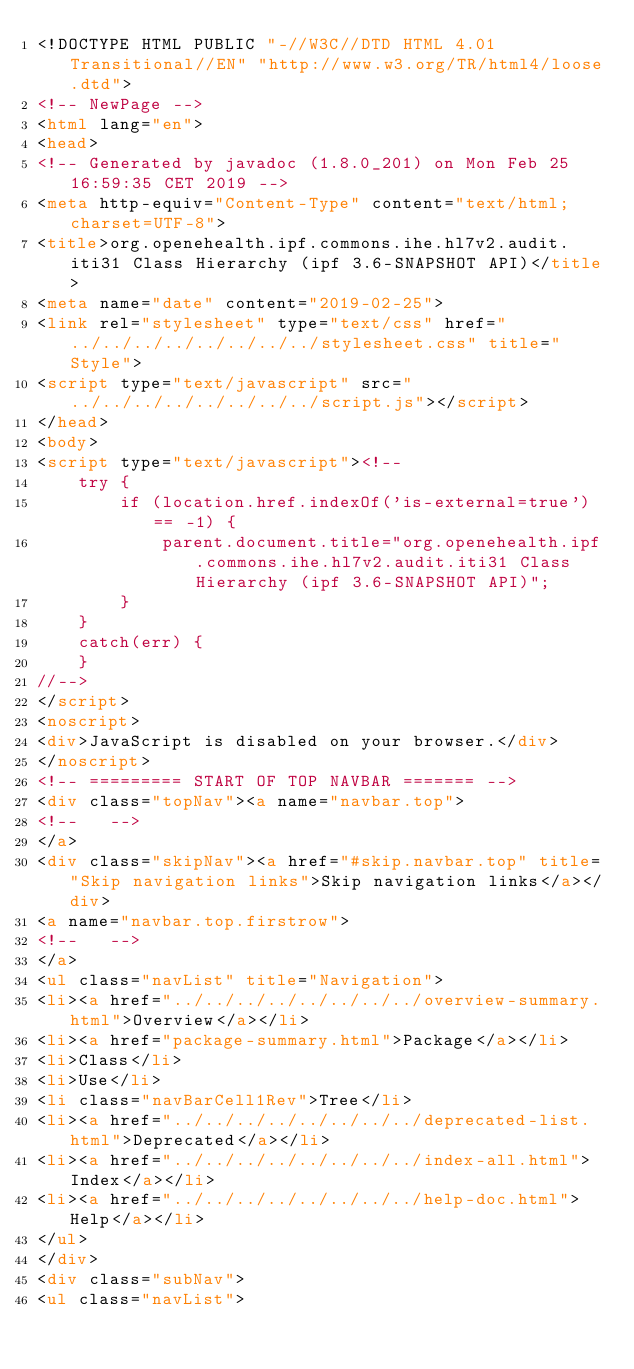Convert code to text. <code><loc_0><loc_0><loc_500><loc_500><_HTML_><!DOCTYPE HTML PUBLIC "-//W3C//DTD HTML 4.01 Transitional//EN" "http://www.w3.org/TR/html4/loose.dtd">
<!-- NewPage -->
<html lang="en">
<head>
<!-- Generated by javadoc (1.8.0_201) on Mon Feb 25 16:59:35 CET 2019 -->
<meta http-equiv="Content-Type" content="text/html; charset=UTF-8">
<title>org.openehealth.ipf.commons.ihe.hl7v2.audit.iti31 Class Hierarchy (ipf 3.6-SNAPSHOT API)</title>
<meta name="date" content="2019-02-25">
<link rel="stylesheet" type="text/css" href="../../../../../../../../stylesheet.css" title="Style">
<script type="text/javascript" src="../../../../../../../../script.js"></script>
</head>
<body>
<script type="text/javascript"><!--
    try {
        if (location.href.indexOf('is-external=true') == -1) {
            parent.document.title="org.openehealth.ipf.commons.ihe.hl7v2.audit.iti31 Class Hierarchy (ipf 3.6-SNAPSHOT API)";
        }
    }
    catch(err) {
    }
//-->
</script>
<noscript>
<div>JavaScript is disabled on your browser.</div>
</noscript>
<!-- ========= START OF TOP NAVBAR ======= -->
<div class="topNav"><a name="navbar.top">
<!--   -->
</a>
<div class="skipNav"><a href="#skip.navbar.top" title="Skip navigation links">Skip navigation links</a></div>
<a name="navbar.top.firstrow">
<!--   -->
</a>
<ul class="navList" title="Navigation">
<li><a href="../../../../../../../../overview-summary.html">Overview</a></li>
<li><a href="package-summary.html">Package</a></li>
<li>Class</li>
<li>Use</li>
<li class="navBarCell1Rev">Tree</li>
<li><a href="../../../../../../../../deprecated-list.html">Deprecated</a></li>
<li><a href="../../../../../../../../index-all.html">Index</a></li>
<li><a href="../../../../../../../../help-doc.html">Help</a></li>
</ul>
</div>
<div class="subNav">
<ul class="navList"></code> 